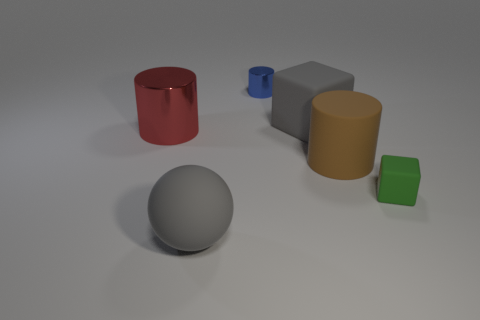Subtract all blue cylinders. How many cylinders are left? 2 Subtract all blue cylinders. How many cylinders are left? 2 Subtract 2 cylinders. How many cylinders are left? 1 Subtract all blocks. How many objects are left? 4 Subtract all brown spheres. How many red cylinders are left? 1 Subtract all large brown rubber objects. Subtract all tiny blue metallic objects. How many objects are left? 4 Add 6 tiny blue shiny things. How many tiny blue shiny things are left? 7 Add 6 green blocks. How many green blocks exist? 7 Add 4 big red metal spheres. How many objects exist? 10 Subtract 0 yellow balls. How many objects are left? 6 